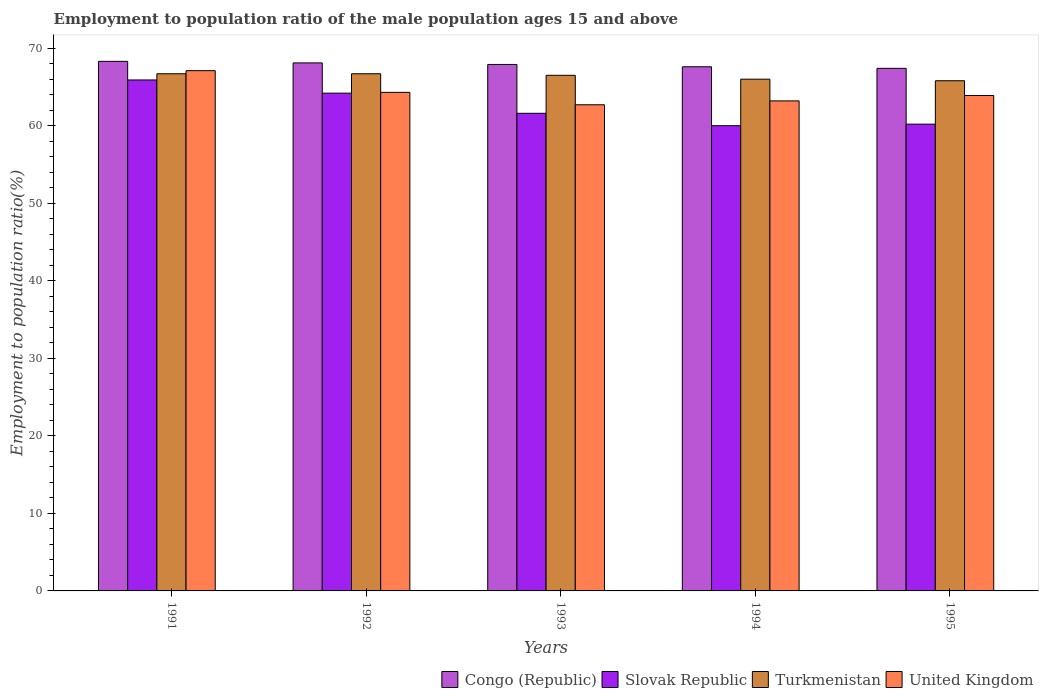How many different coloured bars are there?
Provide a succinct answer. 4. How many groups of bars are there?
Ensure brevity in your answer.  5. Are the number of bars per tick equal to the number of legend labels?
Offer a very short reply. Yes. Are the number of bars on each tick of the X-axis equal?
Provide a succinct answer. Yes. How many bars are there on the 5th tick from the left?
Offer a very short reply. 4. How many bars are there on the 3rd tick from the right?
Offer a very short reply. 4. What is the label of the 4th group of bars from the left?
Offer a terse response. 1994. What is the employment to population ratio in United Kingdom in 1991?
Make the answer very short. 67.1. Across all years, what is the maximum employment to population ratio in Turkmenistan?
Ensure brevity in your answer.  66.7. Across all years, what is the minimum employment to population ratio in United Kingdom?
Your answer should be compact. 62.7. What is the total employment to population ratio in Slovak Republic in the graph?
Your answer should be very brief. 311.9. What is the difference between the employment to population ratio in Turkmenistan in 1992 and that in 1994?
Offer a terse response. 0.7. What is the difference between the employment to population ratio in Congo (Republic) in 1992 and the employment to population ratio in Turkmenistan in 1993?
Give a very brief answer. 1.6. What is the average employment to population ratio in Slovak Republic per year?
Make the answer very short. 62.38. In the year 1992, what is the difference between the employment to population ratio in Slovak Republic and employment to population ratio in United Kingdom?
Provide a succinct answer. -0.1. In how many years, is the employment to population ratio in Slovak Republic greater than 4 %?
Provide a short and direct response. 5. What is the ratio of the employment to population ratio in Congo (Republic) in 1991 to that in 1992?
Ensure brevity in your answer.  1. What is the difference between the highest and the second highest employment to population ratio in Slovak Republic?
Ensure brevity in your answer.  1.7. What is the difference between the highest and the lowest employment to population ratio in United Kingdom?
Provide a succinct answer. 4.4. Is it the case that in every year, the sum of the employment to population ratio in Congo (Republic) and employment to population ratio in United Kingdom is greater than the sum of employment to population ratio in Slovak Republic and employment to population ratio in Turkmenistan?
Provide a short and direct response. No. What does the 2nd bar from the left in 1995 represents?
Your answer should be compact. Slovak Republic. What does the 2nd bar from the right in 1995 represents?
Offer a terse response. Turkmenistan. How many bars are there?
Your answer should be compact. 20. Are all the bars in the graph horizontal?
Offer a terse response. No. How many years are there in the graph?
Your response must be concise. 5. Does the graph contain any zero values?
Your answer should be compact. No. Does the graph contain grids?
Your answer should be compact. No. Where does the legend appear in the graph?
Your response must be concise. Bottom right. How are the legend labels stacked?
Ensure brevity in your answer.  Horizontal. What is the title of the graph?
Provide a short and direct response. Employment to population ratio of the male population ages 15 and above. Does "High income" appear as one of the legend labels in the graph?
Your response must be concise. No. What is the label or title of the Y-axis?
Offer a very short reply. Employment to population ratio(%). What is the Employment to population ratio(%) of Congo (Republic) in 1991?
Offer a terse response. 68.3. What is the Employment to population ratio(%) of Slovak Republic in 1991?
Ensure brevity in your answer.  65.9. What is the Employment to population ratio(%) of Turkmenistan in 1991?
Make the answer very short. 66.7. What is the Employment to population ratio(%) of United Kingdom in 1991?
Keep it short and to the point. 67.1. What is the Employment to population ratio(%) of Congo (Republic) in 1992?
Give a very brief answer. 68.1. What is the Employment to population ratio(%) of Slovak Republic in 1992?
Provide a short and direct response. 64.2. What is the Employment to population ratio(%) in Turkmenistan in 1992?
Your answer should be compact. 66.7. What is the Employment to population ratio(%) in United Kingdom in 1992?
Ensure brevity in your answer.  64.3. What is the Employment to population ratio(%) in Congo (Republic) in 1993?
Offer a terse response. 67.9. What is the Employment to population ratio(%) in Slovak Republic in 1993?
Ensure brevity in your answer.  61.6. What is the Employment to population ratio(%) in Turkmenistan in 1993?
Your answer should be compact. 66.5. What is the Employment to population ratio(%) of United Kingdom in 1993?
Provide a succinct answer. 62.7. What is the Employment to population ratio(%) of Congo (Republic) in 1994?
Provide a short and direct response. 67.6. What is the Employment to population ratio(%) in Slovak Republic in 1994?
Provide a succinct answer. 60. What is the Employment to population ratio(%) of Turkmenistan in 1994?
Offer a terse response. 66. What is the Employment to population ratio(%) in United Kingdom in 1994?
Keep it short and to the point. 63.2. What is the Employment to population ratio(%) of Congo (Republic) in 1995?
Offer a terse response. 67.4. What is the Employment to population ratio(%) of Slovak Republic in 1995?
Offer a terse response. 60.2. What is the Employment to population ratio(%) of Turkmenistan in 1995?
Your answer should be compact. 65.8. What is the Employment to population ratio(%) of United Kingdom in 1995?
Provide a succinct answer. 63.9. Across all years, what is the maximum Employment to population ratio(%) in Congo (Republic)?
Provide a short and direct response. 68.3. Across all years, what is the maximum Employment to population ratio(%) in Slovak Republic?
Provide a succinct answer. 65.9. Across all years, what is the maximum Employment to population ratio(%) in Turkmenistan?
Your answer should be very brief. 66.7. Across all years, what is the maximum Employment to population ratio(%) in United Kingdom?
Your answer should be very brief. 67.1. Across all years, what is the minimum Employment to population ratio(%) of Congo (Republic)?
Your answer should be very brief. 67.4. Across all years, what is the minimum Employment to population ratio(%) of Slovak Republic?
Make the answer very short. 60. Across all years, what is the minimum Employment to population ratio(%) of Turkmenistan?
Your answer should be very brief. 65.8. Across all years, what is the minimum Employment to population ratio(%) of United Kingdom?
Your answer should be compact. 62.7. What is the total Employment to population ratio(%) of Congo (Republic) in the graph?
Keep it short and to the point. 339.3. What is the total Employment to population ratio(%) of Slovak Republic in the graph?
Ensure brevity in your answer.  311.9. What is the total Employment to population ratio(%) of Turkmenistan in the graph?
Ensure brevity in your answer.  331.7. What is the total Employment to population ratio(%) in United Kingdom in the graph?
Your answer should be compact. 321.2. What is the difference between the Employment to population ratio(%) in Congo (Republic) in 1991 and that in 1992?
Offer a very short reply. 0.2. What is the difference between the Employment to population ratio(%) in Slovak Republic in 1991 and that in 1992?
Provide a short and direct response. 1.7. What is the difference between the Employment to population ratio(%) of Turkmenistan in 1991 and that in 1992?
Keep it short and to the point. 0. What is the difference between the Employment to population ratio(%) of Congo (Republic) in 1991 and that in 1993?
Keep it short and to the point. 0.4. What is the difference between the Employment to population ratio(%) of United Kingdom in 1991 and that in 1993?
Ensure brevity in your answer.  4.4. What is the difference between the Employment to population ratio(%) in Slovak Republic in 1991 and that in 1994?
Give a very brief answer. 5.9. What is the difference between the Employment to population ratio(%) of Congo (Republic) in 1991 and that in 1995?
Provide a short and direct response. 0.9. What is the difference between the Employment to population ratio(%) of Slovak Republic in 1991 and that in 1995?
Your response must be concise. 5.7. What is the difference between the Employment to population ratio(%) in Turkmenistan in 1991 and that in 1995?
Offer a very short reply. 0.9. What is the difference between the Employment to population ratio(%) of United Kingdom in 1991 and that in 1995?
Your answer should be very brief. 3.2. What is the difference between the Employment to population ratio(%) of Slovak Republic in 1992 and that in 1993?
Provide a short and direct response. 2.6. What is the difference between the Employment to population ratio(%) of Congo (Republic) in 1992 and that in 1994?
Your answer should be compact. 0.5. What is the difference between the Employment to population ratio(%) of Turkmenistan in 1992 and that in 1994?
Keep it short and to the point. 0.7. What is the difference between the Employment to population ratio(%) of Slovak Republic in 1992 and that in 1995?
Provide a succinct answer. 4. What is the difference between the Employment to population ratio(%) in Turkmenistan in 1992 and that in 1995?
Give a very brief answer. 0.9. What is the difference between the Employment to population ratio(%) of United Kingdom in 1992 and that in 1995?
Keep it short and to the point. 0.4. What is the difference between the Employment to population ratio(%) in Slovak Republic in 1993 and that in 1994?
Offer a very short reply. 1.6. What is the difference between the Employment to population ratio(%) of Turkmenistan in 1993 and that in 1994?
Offer a terse response. 0.5. What is the difference between the Employment to population ratio(%) of United Kingdom in 1993 and that in 1994?
Give a very brief answer. -0.5. What is the difference between the Employment to population ratio(%) in Congo (Republic) in 1993 and that in 1995?
Provide a short and direct response. 0.5. What is the difference between the Employment to population ratio(%) in Turkmenistan in 1993 and that in 1995?
Make the answer very short. 0.7. What is the difference between the Employment to population ratio(%) in Congo (Republic) in 1994 and that in 1995?
Provide a short and direct response. 0.2. What is the difference between the Employment to population ratio(%) of Slovak Republic in 1994 and that in 1995?
Ensure brevity in your answer.  -0.2. What is the difference between the Employment to population ratio(%) in Turkmenistan in 1994 and that in 1995?
Your answer should be compact. 0.2. What is the difference between the Employment to population ratio(%) in Congo (Republic) in 1991 and the Employment to population ratio(%) in Slovak Republic in 1992?
Your response must be concise. 4.1. What is the difference between the Employment to population ratio(%) of Congo (Republic) in 1991 and the Employment to population ratio(%) of Turkmenistan in 1992?
Your answer should be compact. 1.6. What is the difference between the Employment to population ratio(%) of Congo (Republic) in 1991 and the Employment to population ratio(%) of United Kingdom in 1992?
Your answer should be compact. 4. What is the difference between the Employment to population ratio(%) in Slovak Republic in 1991 and the Employment to population ratio(%) in Turkmenistan in 1992?
Provide a succinct answer. -0.8. What is the difference between the Employment to population ratio(%) in Congo (Republic) in 1991 and the Employment to population ratio(%) in Turkmenistan in 1993?
Offer a terse response. 1.8. What is the difference between the Employment to population ratio(%) of Congo (Republic) in 1991 and the Employment to population ratio(%) of United Kingdom in 1993?
Provide a succinct answer. 5.6. What is the difference between the Employment to population ratio(%) in Slovak Republic in 1991 and the Employment to population ratio(%) in Turkmenistan in 1993?
Your answer should be compact. -0.6. What is the difference between the Employment to population ratio(%) of Slovak Republic in 1991 and the Employment to population ratio(%) of United Kingdom in 1993?
Keep it short and to the point. 3.2. What is the difference between the Employment to population ratio(%) in Turkmenistan in 1991 and the Employment to population ratio(%) in United Kingdom in 1993?
Provide a succinct answer. 4. What is the difference between the Employment to population ratio(%) of Congo (Republic) in 1991 and the Employment to population ratio(%) of Slovak Republic in 1994?
Give a very brief answer. 8.3. What is the difference between the Employment to population ratio(%) of Slovak Republic in 1991 and the Employment to population ratio(%) of Turkmenistan in 1994?
Offer a terse response. -0.1. What is the difference between the Employment to population ratio(%) in Congo (Republic) in 1991 and the Employment to population ratio(%) in Turkmenistan in 1995?
Offer a very short reply. 2.5. What is the difference between the Employment to population ratio(%) of Slovak Republic in 1991 and the Employment to population ratio(%) of Turkmenistan in 1995?
Provide a succinct answer. 0.1. What is the difference between the Employment to population ratio(%) in Slovak Republic in 1991 and the Employment to population ratio(%) in United Kingdom in 1995?
Offer a very short reply. 2. What is the difference between the Employment to population ratio(%) in Congo (Republic) in 1992 and the Employment to population ratio(%) in Slovak Republic in 1993?
Give a very brief answer. 6.5. What is the difference between the Employment to population ratio(%) in Congo (Republic) in 1992 and the Employment to population ratio(%) in Slovak Republic in 1994?
Offer a very short reply. 8.1. What is the difference between the Employment to population ratio(%) in Congo (Republic) in 1992 and the Employment to population ratio(%) in Turkmenistan in 1994?
Provide a short and direct response. 2.1. What is the difference between the Employment to population ratio(%) of Slovak Republic in 1992 and the Employment to population ratio(%) of Turkmenistan in 1994?
Your answer should be very brief. -1.8. What is the difference between the Employment to population ratio(%) of Slovak Republic in 1992 and the Employment to population ratio(%) of United Kingdom in 1994?
Provide a succinct answer. 1. What is the difference between the Employment to population ratio(%) in Congo (Republic) in 1992 and the Employment to population ratio(%) in Slovak Republic in 1995?
Offer a terse response. 7.9. What is the difference between the Employment to population ratio(%) of Congo (Republic) in 1992 and the Employment to population ratio(%) of Turkmenistan in 1995?
Make the answer very short. 2.3. What is the difference between the Employment to population ratio(%) in Congo (Republic) in 1992 and the Employment to population ratio(%) in United Kingdom in 1995?
Offer a very short reply. 4.2. What is the difference between the Employment to population ratio(%) in Slovak Republic in 1992 and the Employment to population ratio(%) in Turkmenistan in 1995?
Your answer should be compact. -1.6. What is the difference between the Employment to population ratio(%) in Turkmenistan in 1992 and the Employment to population ratio(%) in United Kingdom in 1995?
Give a very brief answer. 2.8. What is the difference between the Employment to population ratio(%) in Congo (Republic) in 1993 and the Employment to population ratio(%) in Slovak Republic in 1994?
Your answer should be very brief. 7.9. What is the difference between the Employment to population ratio(%) of Congo (Republic) in 1993 and the Employment to population ratio(%) of United Kingdom in 1994?
Provide a succinct answer. 4.7. What is the difference between the Employment to population ratio(%) of Slovak Republic in 1993 and the Employment to population ratio(%) of United Kingdom in 1995?
Offer a terse response. -2.3. What is the difference between the Employment to population ratio(%) of Turkmenistan in 1993 and the Employment to population ratio(%) of United Kingdom in 1995?
Provide a succinct answer. 2.6. What is the difference between the Employment to population ratio(%) in Congo (Republic) in 1994 and the Employment to population ratio(%) in Slovak Republic in 1995?
Give a very brief answer. 7.4. What is the difference between the Employment to population ratio(%) in Congo (Republic) in 1994 and the Employment to population ratio(%) in United Kingdom in 1995?
Make the answer very short. 3.7. What is the difference between the Employment to population ratio(%) of Slovak Republic in 1994 and the Employment to population ratio(%) of Turkmenistan in 1995?
Offer a very short reply. -5.8. What is the difference between the Employment to population ratio(%) in Slovak Republic in 1994 and the Employment to population ratio(%) in United Kingdom in 1995?
Provide a succinct answer. -3.9. What is the average Employment to population ratio(%) in Congo (Republic) per year?
Your answer should be compact. 67.86. What is the average Employment to population ratio(%) of Slovak Republic per year?
Offer a very short reply. 62.38. What is the average Employment to population ratio(%) in Turkmenistan per year?
Give a very brief answer. 66.34. What is the average Employment to population ratio(%) of United Kingdom per year?
Your answer should be compact. 64.24. In the year 1991, what is the difference between the Employment to population ratio(%) in Congo (Republic) and Employment to population ratio(%) in Slovak Republic?
Ensure brevity in your answer.  2.4. In the year 1991, what is the difference between the Employment to population ratio(%) in Congo (Republic) and Employment to population ratio(%) in Turkmenistan?
Keep it short and to the point. 1.6. In the year 1991, what is the difference between the Employment to population ratio(%) of Slovak Republic and Employment to population ratio(%) of Turkmenistan?
Your answer should be very brief. -0.8. In the year 1991, what is the difference between the Employment to population ratio(%) of Turkmenistan and Employment to population ratio(%) of United Kingdom?
Your answer should be very brief. -0.4. In the year 1992, what is the difference between the Employment to population ratio(%) in Slovak Republic and Employment to population ratio(%) in United Kingdom?
Ensure brevity in your answer.  -0.1. In the year 1993, what is the difference between the Employment to population ratio(%) of Congo (Republic) and Employment to population ratio(%) of Slovak Republic?
Keep it short and to the point. 6.3. In the year 1993, what is the difference between the Employment to population ratio(%) of Slovak Republic and Employment to population ratio(%) of Turkmenistan?
Provide a short and direct response. -4.9. In the year 1994, what is the difference between the Employment to population ratio(%) in Congo (Republic) and Employment to population ratio(%) in Slovak Republic?
Provide a succinct answer. 7.6. In the year 1994, what is the difference between the Employment to population ratio(%) of Congo (Republic) and Employment to population ratio(%) of Turkmenistan?
Your response must be concise. 1.6. In the year 1994, what is the difference between the Employment to population ratio(%) in Congo (Republic) and Employment to population ratio(%) in United Kingdom?
Your response must be concise. 4.4. In the year 1994, what is the difference between the Employment to population ratio(%) of Slovak Republic and Employment to population ratio(%) of United Kingdom?
Your answer should be compact. -3.2. In the year 1995, what is the difference between the Employment to population ratio(%) of Congo (Republic) and Employment to population ratio(%) of Turkmenistan?
Provide a succinct answer. 1.6. In the year 1995, what is the difference between the Employment to population ratio(%) of Congo (Republic) and Employment to population ratio(%) of United Kingdom?
Your response must be concise. 3.5. In the year 1995, what is the difference between the Employment to population ratio(%) of Slovak Republic and Employment to population ratio(%) of Turkmenistan?
Offer a terse response. -5.6. In the year 1995, what is the difference between the Employment to population ratio(%) in Slovak Republic and Employment to population ratio(%) in United Kingdom?
Your response must be concise. -3.7. What is the ratio of the Employment to population ratio(%) in Congo (Republic) in 1991 to that in 1992?
Give a very brief answer. 1. What is the ratio of the Employment to population ratio(%) in Slovak Republic in 1991 to that in 1992?
Provide a succinct answer. 1.03. What is the ratio of the Employment to population ratio(%) in Turkmenistan in 1991 to that in 1992?
Make the answer very short. 1. What is the ratio of the Employment to population ratio(%) in United Kingdom in 1991 to that in 1992?
Offer a terse response. 1.04. What is the ratio of the Employment to population ratio(%) of Congo (Republic) in 1991 to that in 1993?
Provide a succinct answer. 1.01. What is the ratio of the Employment to population ratio(%) of Slovak Republic in 1991 to that in 1993?
Your answer should be very brief. 1.07. What is the ratio of the Employment to population ratio(%) of Turkmenistan in 1991 to that in 1993?
Give a very brief answer. 1. What is the ratio of the Employment to population ratio(%) of United Kingdom in 1991 to that in 1993?
Ensure brevity in your answer.  1.07. What is the ratio of the Employment to population ratio(%) of Congo (Republic) in 1991 to that in 1994?
Your response must be concise. 1.01. What is the ratio of the Employment to population ratio(%) of Slovak Republic in 1991 to that in 1994?
Offer a very short reply. 1.1. What is the ratio of the Employment to population ratio(%) in Turkmenistan in 1991 to that in 1994?
Give a very brief answer. 1.01. What is the ratio of the Employment to population ratio(%) of United Kingdom in 1991 to that in 1994?
Provide a succinct answer. 1.06. What is the ratio of the Employment to population ratio(%) in Congo (Republic) in 1991 to that in 1995?
Offer a terse response. 1.01. What is the ratio of the Employment to population ratio(%) in Slovak Republic in 1991 to that in 1995?
Your response must be concise. 1.09. What is the ratio of the Employment to population ratio(%) in Turkmenistan in 1991 to that in 1995?
Provide a short and direct response. 1.01. What is the ratio of the Employment to population ratio(%) of United Kingdom in 1991 to that in 1995?
Your answer should be compact. 1.05. What is the ratio of the Employment to population ratio(%) in Congo (Republic) in 1992 to that in 1993?
Keep it short and to the point. 1. What is the ratio of the Employment to population ratio(%) of Slovak Republic in 1992 to that in 1993?
Your answer should be very brief. 1.04. What is the ratio of the Employment to population ratio(%) in United Kingdom in 1992 to that in 1993?
Give a very brief answer. 1.03. What is the ratio of the Employment to population ratio(%) of Congo (Republic) in 1992 to that in 1994?
Your answer should be compact. 1.01. What is the ratio of the Employment to population ratio(%) of Slovak Republic in 1992 to that in 1994?
Your response must be concise. 1.07. What is the ratio of the Employment to population ratio(%) in Turkmenistan in 1992 to that in 1994?
Provide a short and direct response. 1.01. What is the ratio of the Employment to population ratio(%) of United Kingdom in 1992 to that in 1994?
Your answer should be very brief. 1.02. What is the ratio of the Employment to population ratio(%) of Congo (Republic) in 1992 to that in 1995?
Ensure brevity in your answer.  1.01. What is the ratio of the Employment to population ratio(%) in Slovak Republic in 1992 to that in 1995?
Provide a succinct answer. 1.07. What is the ratio of the Employment to population ratio(%) in Turkmenistan in 1992 to that in 1995?
Your answer should be compact. 1.01. What is the ratio of the Employment to population ratio(%) of United Kingdom in 1992 to that in 1995?
Offer a terse response. 1.01. What is the ratio of the Employment to population ratio(%) in Congo (Republic) in 1993 to that in 1994?
Your response must be concise. 1. What is the ratio of the Employment to population ratio(%) of Slovak Republic in 1993 to that in 1994?
Your answer should be compact. 1.03. What is the ratio of the Employment to population ratio(%) of Turkmenistan in 1993 to that in 1994?
Provide a short and direct response. 1.01. What is the ratio of the Employment to population ratio(%) in United Kingdom in 1993 to that in 1994?
Offer a terse response. 0.99. What is the ratio of the Employment to population ratio(%) in Congo (Republic) in 1993 to that in 1995?
Keep it short and to the point. 1.01. What is the ratio of the Employment to population ratio(%) of Slovak Republic in 1993 to that in 1995?
Your response must be concise. 1.02. What is the ratio of the Employment to population ratio(%) in Turkmenistan in 1993 to that in 1995?
Provide a succinct answer. 1.01. What is the ratio of the Employment to population ratio(%) in United Kingdom in 1993 to that in 1995?
Provide a succinct answer. 0.98. What is the ratio of the Employment to population ratio(%) of Congo (Republic) in 1994 to that in 1995?
Your answer should be very brief. 1. What is the ratio of the Employment to population ratio(%) in Turkmenistan in 1994 to that in 1995?
Offer a terse response. 1. What is the ratio of the Employment to population ratio(%) of United Kingdom in 1994 to that in 1995?
Provide a short and direct response. 0.99. What is the difference between the highest and the second highest Employment to population ratio(%) in Congo (Republic)?
Ensure brevity in your answer.  0.2. What is the difference between the highest and the second highest Employment to population ratio(%) in Turkmenistan?
Provide a short and direct response. 0. What is the difference between the highest and the second highest Employment to population ratio(%) in United Kingdom?
Make the answer very short. 2.8. What is the difference between the highest and the lowest Employment to population ratio(%) in Turkmenistan?
Provide a short and direct response. 0.9. 